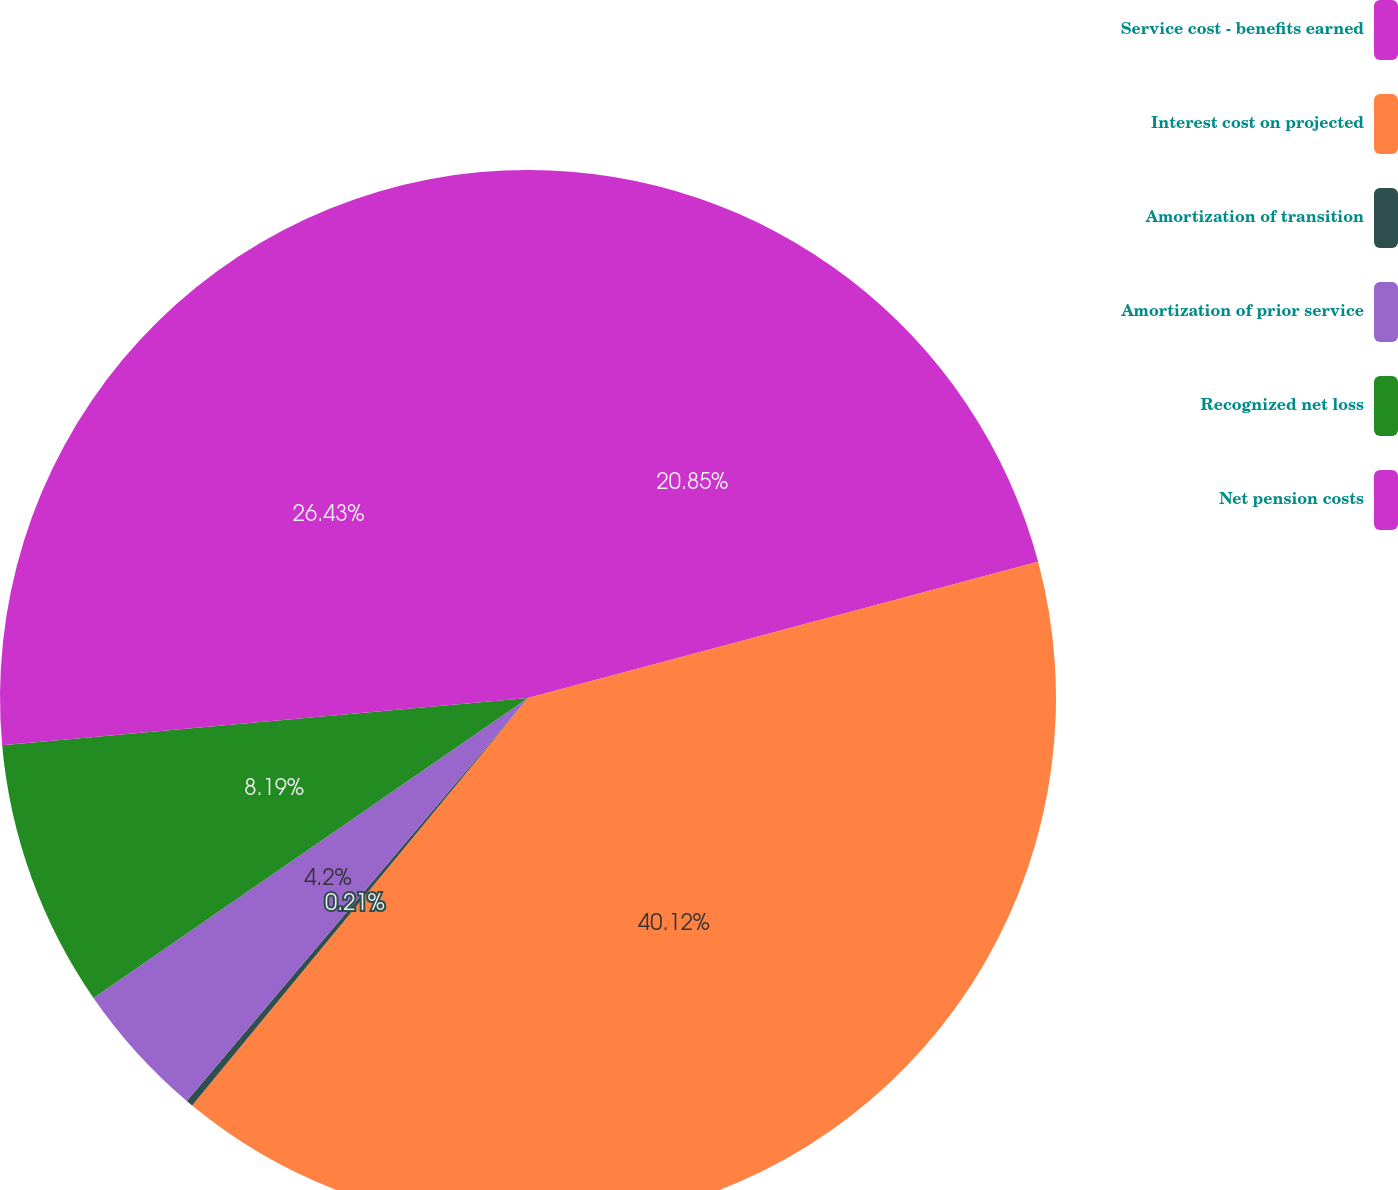Convert chart to OTSL. <chart><loc_0><loc_0><loc_500><loc_500><pie_chart><fcel>Service cost - benefits earned<fcel>Interest cost on projected<fcel>Amortization of transition<fcel>Amortization of prior service<fcel>Recognized net loss<fcel>Net pension costs<nl><fcel>20.85%<fcel>40.13%<fcel>0.21%<fcel>4.2%<fcel>8.19%<fcel>26.43%<nl></chart> 